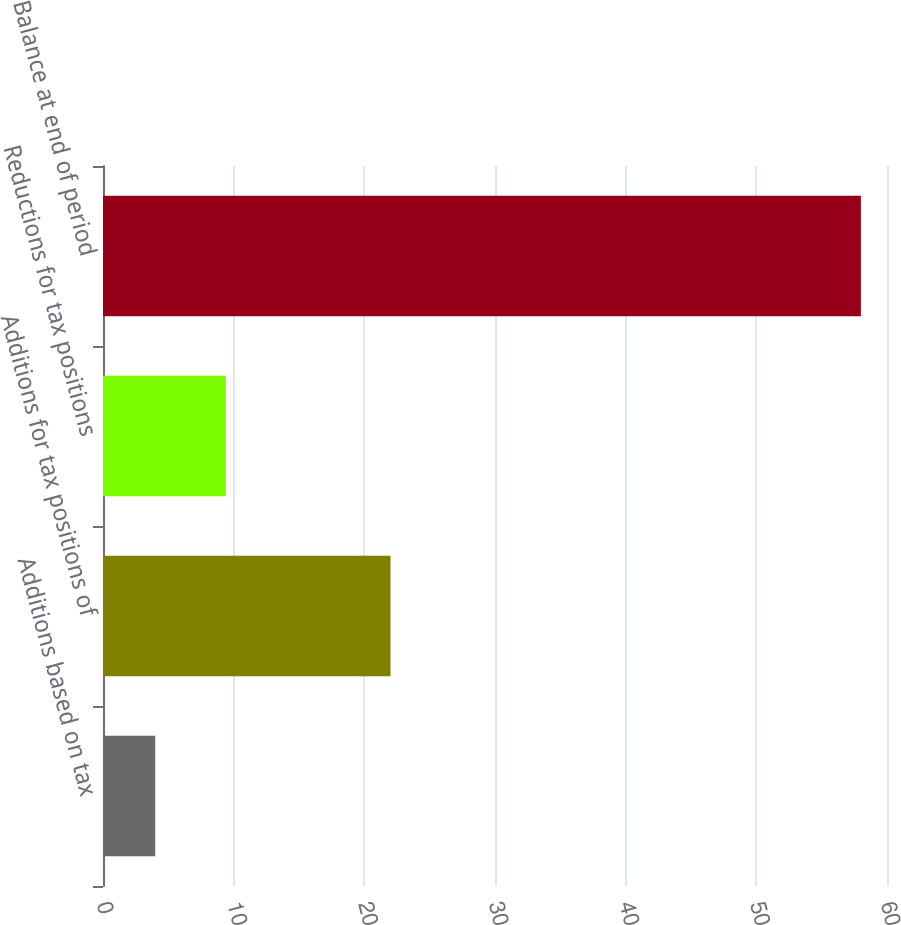Convert chart to OTSL. <chart><loc_0><loc_0><loc_500><loc_500><bar_chart><fcel>Additions based on tax<fcel>Additions for tax positions of<fcel>Reductions for tax positions<fcel>Balance at end of period<nl><fcel>4<fcel>22<fcel>9.4<fcel>58<nl></chart> 